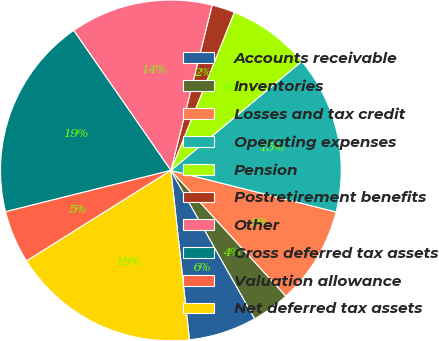<chart> <loc_0><loc_0><loc_500><loc_500><pie_chart><fcel>Accounts receivable<fcel>Inventories<fcel>Losses and tax credit<fcel>Operating expenses<fcel>Pension<fcel>Postretirement benefits<fcel>Other<fcel>Gross deferred tax assets<fcel>Valuation allowance<fcel>Net deferred tax assets<nl><fcel>6.45%<fcel>3.6%<fcel>9.29%<fcel>14.98%<fcel>7.87%<fcel>2.18%<fcel>13.55%<fcel>19.24%<fcel>5.02%<fcel>17.82%<nl></chart> 